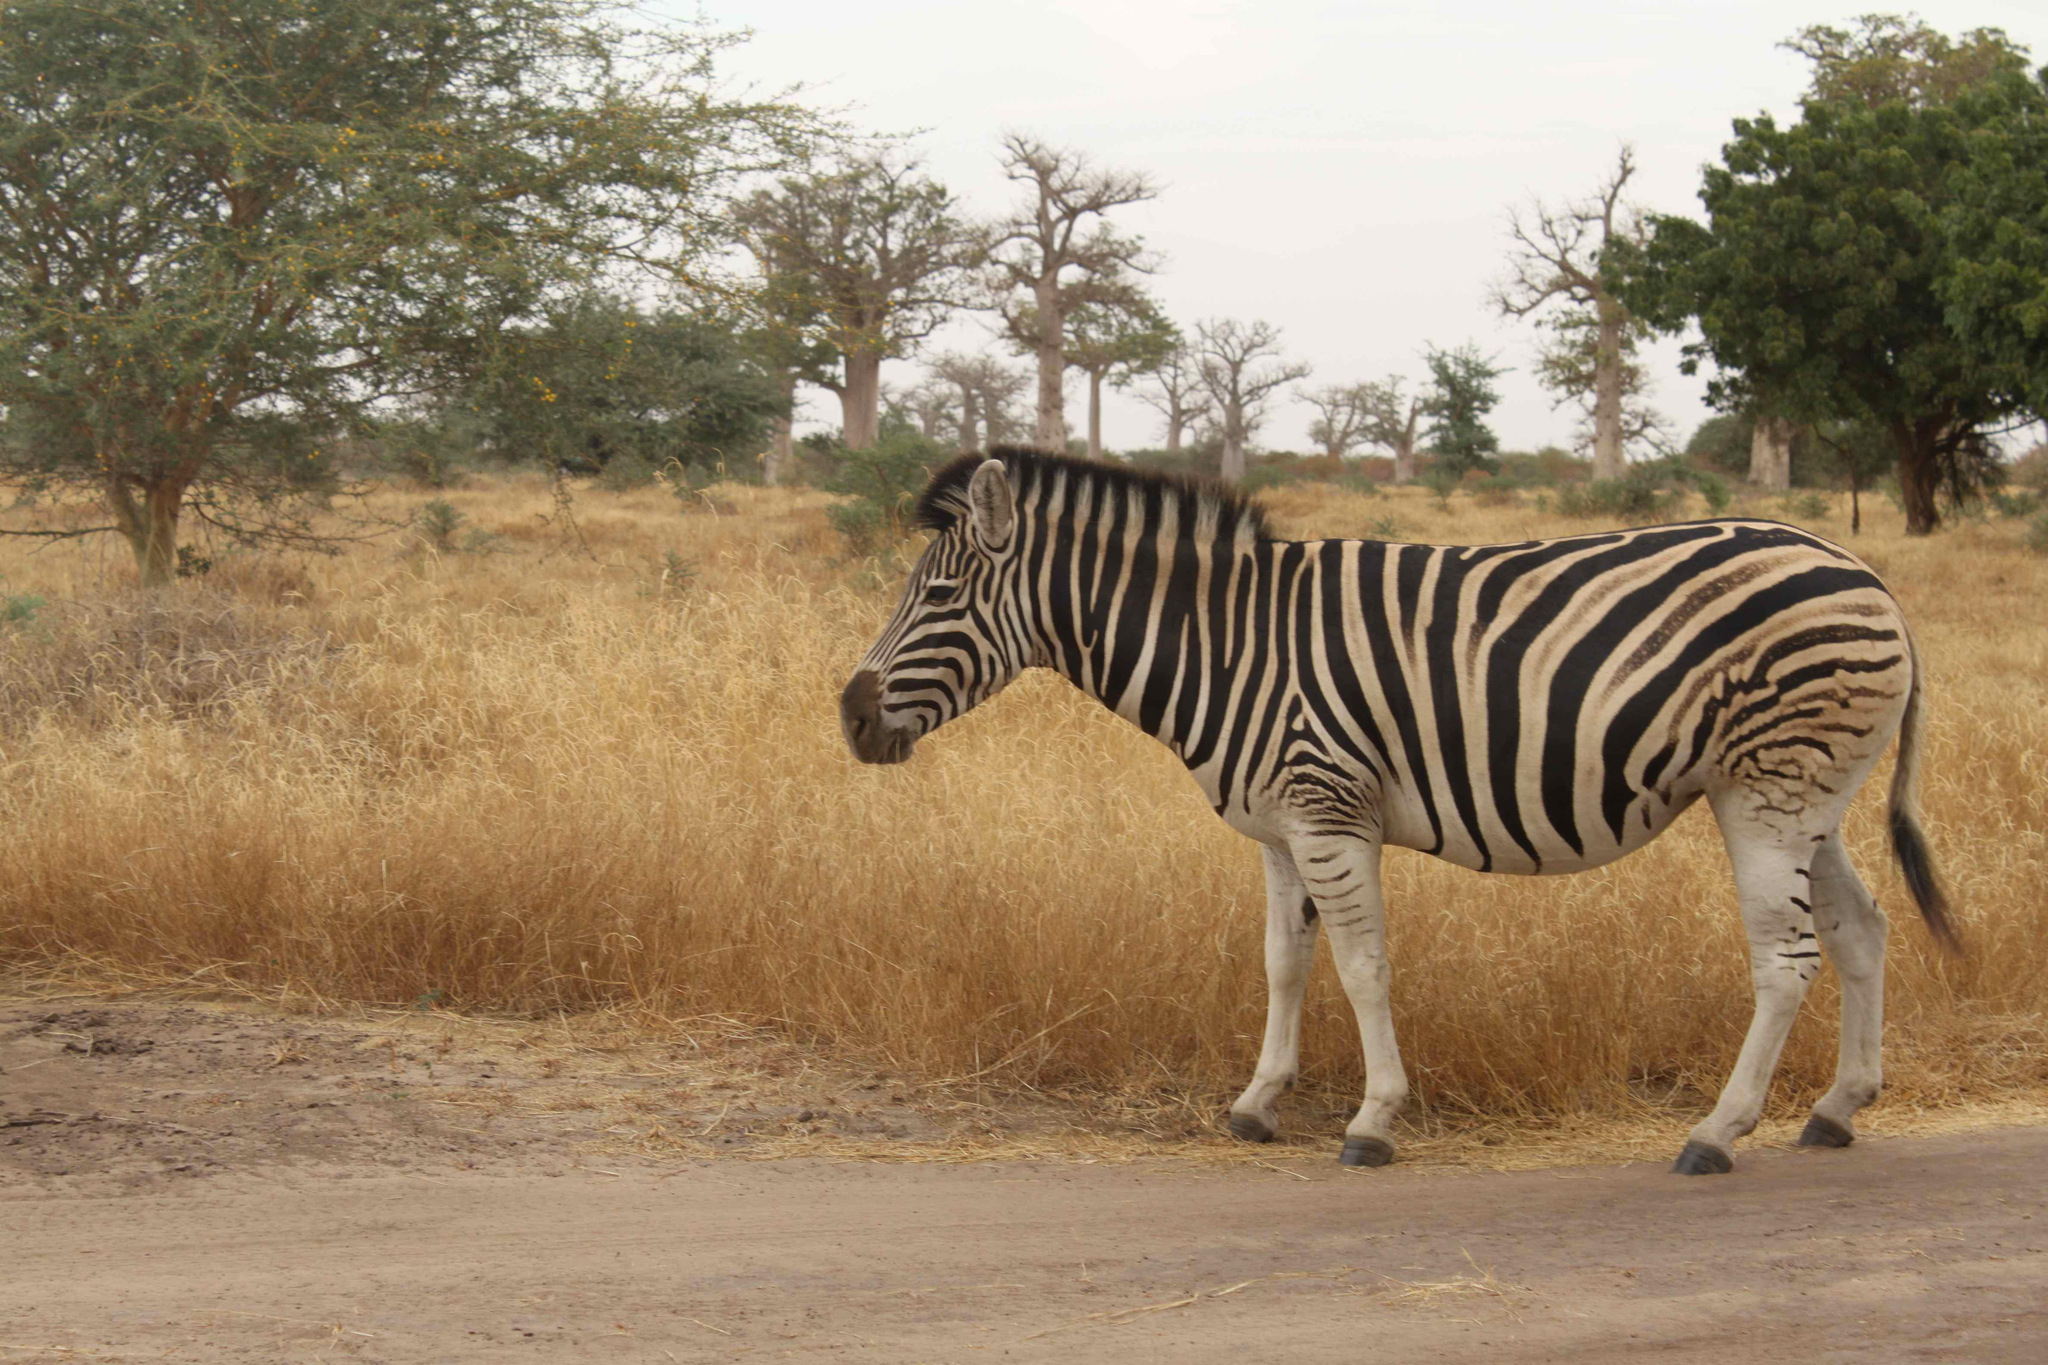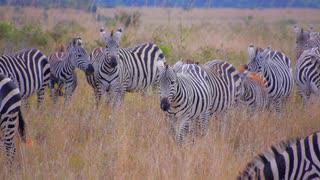The first image is the image on the left, the second image is the image on the right. Examine the images to the left and right. Is the description "The right image contains exactly two zebras." accurate? Answer yes or no. No. The first image is the image on the left, the second image is the image on the right. Considering the images on both sides, is "The left image features a row of no more than seven zebras with bodies mostly parallel to one another and heads raised, and the right image includes zebras with lowered heads." valid? Answer yes or no. No. 